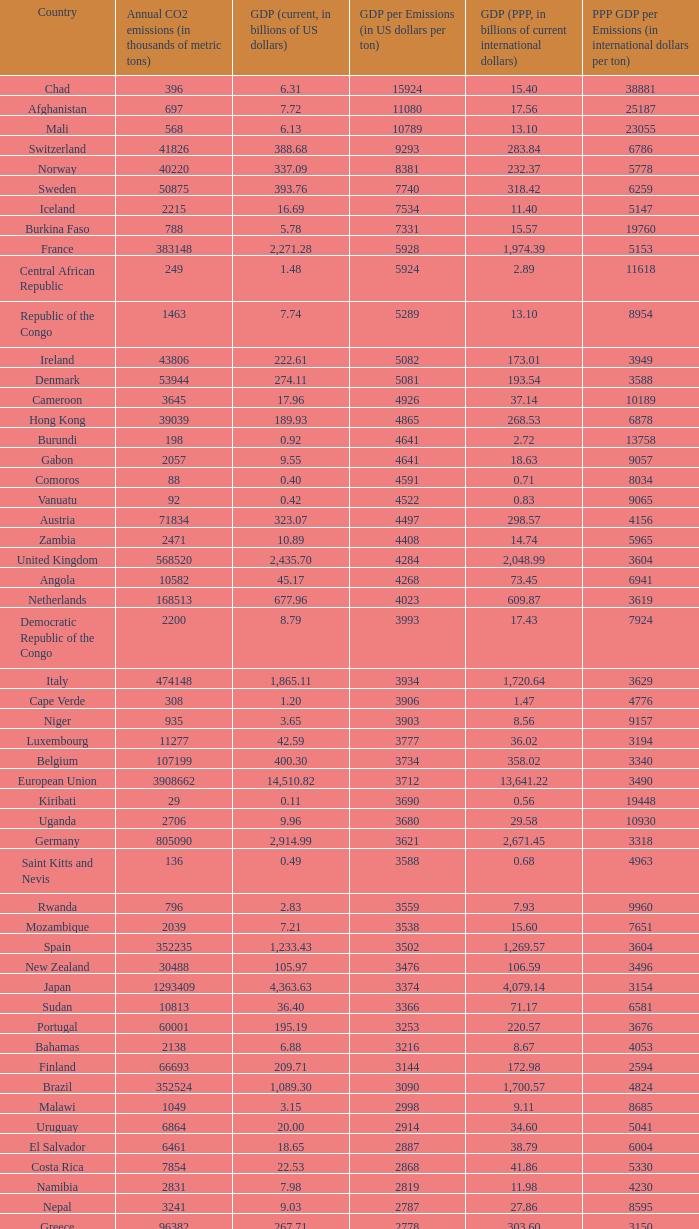When the gdp per emissions (in us dollars per ton) is 3903, what is the maximum annual co2 emissions (in thousands of metric tons)? 935.0. 